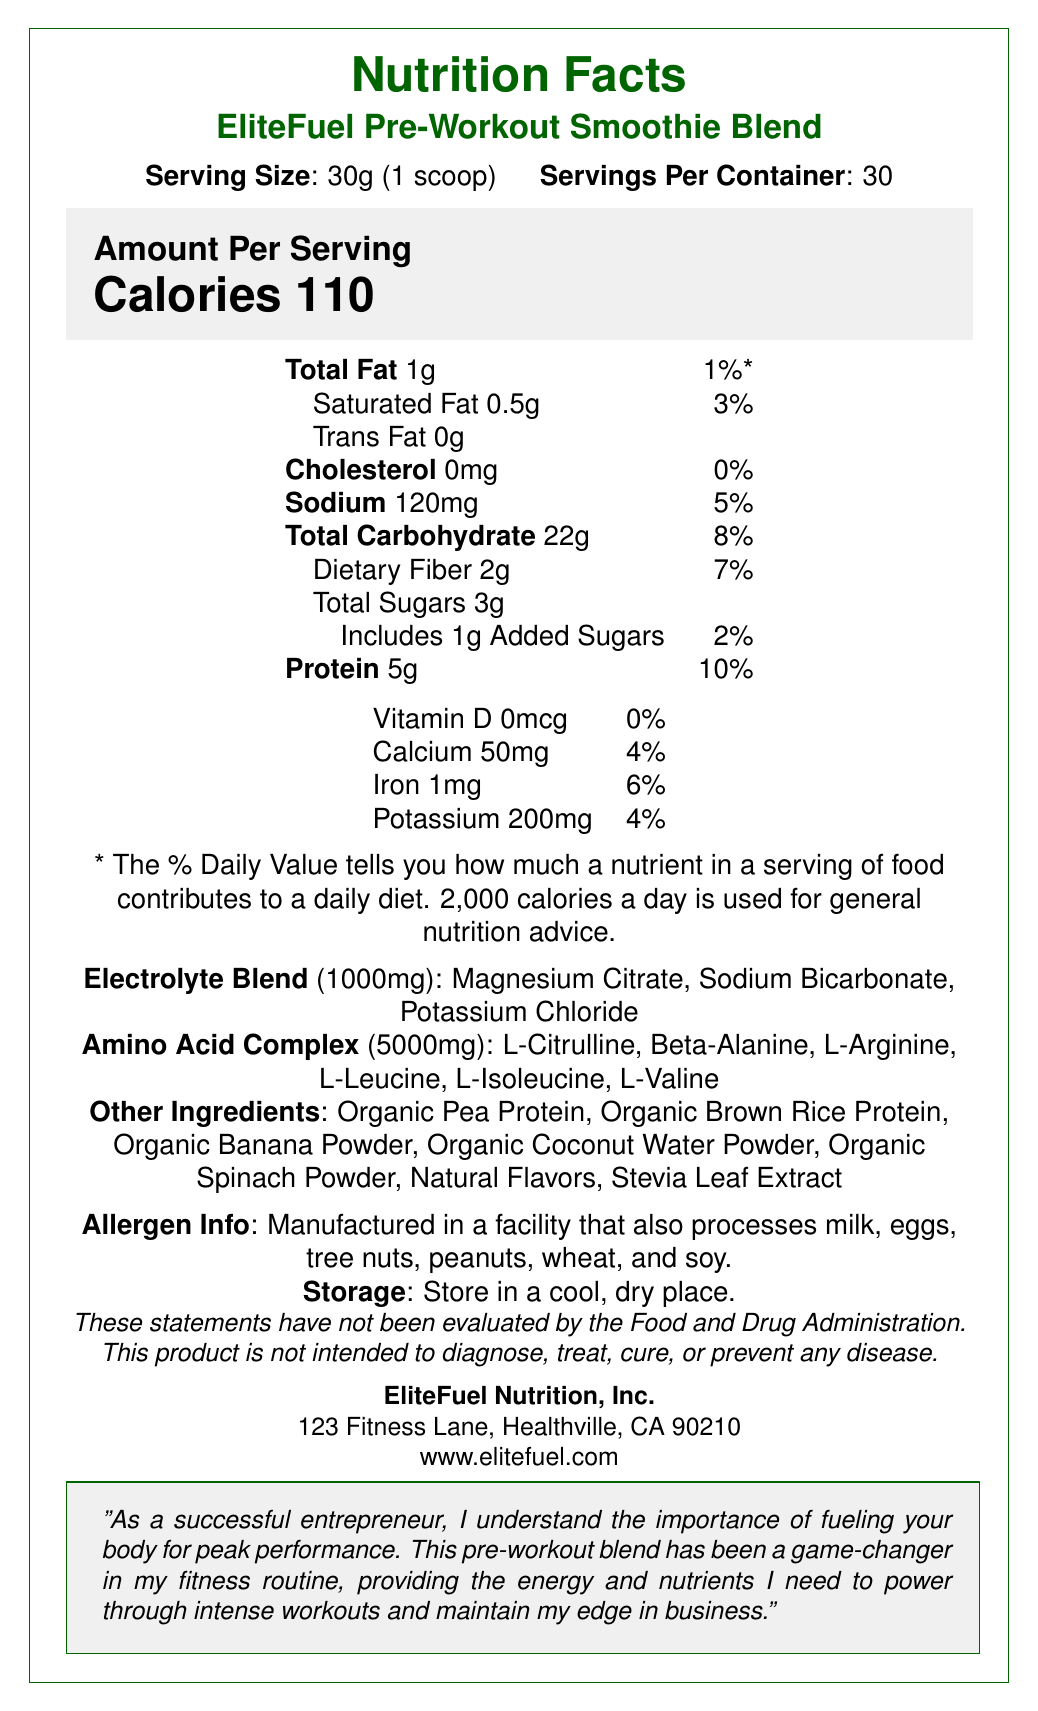How many servings are in the container? The document states "Servings Per Container: 30".
Answer: 30 What is the serving size of the EliteFuel Pre-Workout Smoothie Blend? The document states "Serving Size: 30g (1 scoop)".
Answer: 30g (1 scoop) How many calories are there in one serving? The document states "Calories 110".
Answer: 110 What is the amount of protein in one serving? The document states "Protein 5g".
Answer: 5g Which electrolyte ingredients are included in the blend? The document lists the electrolyte blend ingredients as "Magnesium Citrate, Sodium Bicarbonate, Potassium Chloride".
Answer: Magnesium Citrate, Sodium Bicarbonate, Potassium Chloride What is the daily value percentage for saturated fat in one serving? The document states "Saturated Fat 0.5g" and gives the daily value as "3%".
Answer: 3% What is the serving size of the EliteFuel Pre-Workout Smoothie Blend? A. 20g B. 25g C. 30g D. 35g The document states "Serving Size: 30g (1 scoop)".
Answer: C How much sodium is in one serving? A. 50mg B. 100mg C. 120mg D. 150mg The document states "Sodium 120mg".
Answer: C Is this product intended to diagnose, treat, cure, or prevent any disease? The document includes a disclaimer stating "This product is not intended to diagnose, treat, cure, or prevent any disease".
Answer: No Does one serving of the EliteFuel Pre-Workout Smoothie Blend contain any cholesterol? The document states "Cholesterol 0mg".
Answer: No Summarize the main purpose and content of the nutrition label for the EliteFuel Pre-Workout Smoothie Blend. This description includes the serving size and the nutritional content, lists the special blends, and mentions additional information like allergen info, storage instructions, FDA disclaimer, and a note from an entrepreneur endorsing the product for fitness routines.
Answer: The nutrition label for the EliteFuel Pre-Workout Smoothie Blend provides detailed nutritional information for one serving size of 30g, which includes 110 calories, macronutrients (protein, fats, carbohydrates), micronutrients (vitamins and minerals), and special blends of electrolytes and amino acids. The label highlights the ingredients, allergen information, storage instructions, standard FDA disclaimer, and notes on the product's benefits for fitness routines. How often should I consume the EliteFuel Pre-Workout Smoothie Blend? The document does not provide consumption frequency or guidelines.
Answer: Not enough information What is the amount of added sugars in one serving? The document states "Includes 1g Added Sugars".
Answer: 1g How much dietary fiber does one serving contain? A. 1g B. 2g C. 3g The document states "Dietary Fiber 2g".
Answer: B What is the daily value percentage of iron in one serving? The document states "Iron 1mg" and gives the daily value as "6%".
Answer: 6% 